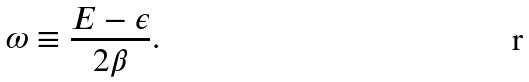Convert formula to latex. <formula><loc_0><loc_0><loc_500><loc_500>\omega \equiv \frac { E - \epsilon } { 2 \beta } .</formula> 